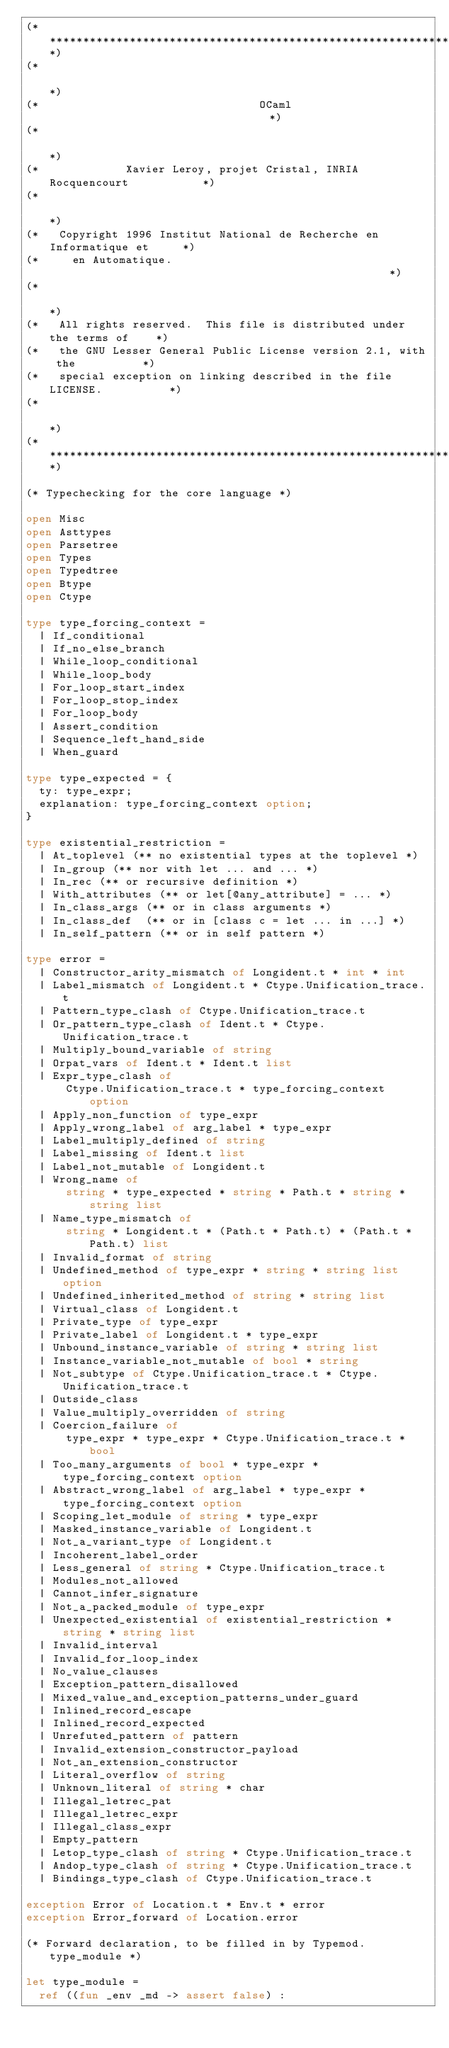<code> <loc_0><loc_0><loc_500><loc_500><_OCaml_>(**************************************************************************)
(*                                                                        *)
(*                                 OCaml                                  *)
(*                                                                        *)
(*             Xavier Leroy, projet Cristal, INRIA Rocquencourt           *)
(*                                                                        *)
(*   Copyright 1996 Institut National de Recherche en Informatique et     *)
(*     en Automatique.                                                    *)
(*                                                                        *)
(*   All rights reserved.  This file is distributed under the terms of    *)
(*   the GNU Lesser General Public License version 2.1, with the          *)
(*   special exception on linking described in the file LICENSE.          *)
(*                                                                        *)
(**************************************************************************)

(* Typechecking for the core language *)

open Misc
open Asttypes
open Parsetree
open Types
open Typedtree
open Btype
open Ctype

type type_forcing_context =
  | If_conditional
  | If_no_else_branch
  | While_loop_conditional
  | While_loop_body
  | For_loop_start_index
  | For_loop_stop_index
  | For_loop_body
  | Assert_condition
  | Sequence_left_hand_side
  | When_guard

type type_expected = {
  ty: type_expr;
  explanation: type_forcing_context option;
}

type existential_restriction =
  | At_toplevel (** no existential types at the toplevel *)
  | In_group (** nor with let ... and ... *)
  | In_rec (** or recursive definition *)
  | With_attributes (** or let[@any_attribute] = ... *)
  | In_class_args (** or in class arguments *)
  | In_class_def  (** or in [class c = let ... in ...] *)
  | In_self_pattern (** or in self pattern *)

type error =
  | Constructor_arity_mismatch of Longident.t * int * int
  | Label_mismatch of Longident.t * Ctype.Unification_trace.t
  | Pattern_type_clash of Ctype.Unification_trace.t
  | Or_pattern_type_clash of Ident.t * Ctype.Unification_trace.t
  | Multiply_bound_variable of string
  | Orpat_vars of Ident.t * Ident.t list
  | Expr_type_clash of
      Ctype.Unification_trace.t * type_forcing_context option
  | Apply_non_function of type_expr
  | Apply_wrong_label of arg_label * type_expr
  | Label_multiply_defined of string
  | Label_missing of Ident.t list
  | Label_not_mutable of Longident.t
  | Wrong_name of
      string * type_expected * string * Path.t * string * string list
  | Name_type_mismatch of
      string * Longident.t * (Path.t * Path.t) * (Path.t * Path.t) list
  | Invalid_format of string
  | Undefined_method of type_expr * string * string list option
  | Undefined_inherited_method of string * string list
  | Virtual_class of Longident.t
  | Private_type of type_expr
  | Private_label of Longident.t * type_expr
  | Unbound_instance_variable of string * string list
  | Instance_variable_not_mutable of bool * string
  | Not_subtype of Ctype.Unification_trace.t * Ctype.Unification_trace.t
  | Outside_class
  | Value_multiply_overridden of string
  | Coercion_failure of
      type_expr * type_expr * Ctype.Unification_trace.t * bool
  | Too_many_arguments of bool * type_expr * type_forcing_context option
  | Abstract_wrong_label of arg_label * type_expr * type_forcing_context option
  | Scoping_let_module of string * type_expr
  | Masked_instance_variable of Longident.t
  | Not_a_variant_type of Longident.t
  | Incoherent_label_order
  | Less_general of string * Ctype.Unification_trace.t
  | Modules_not_allowed
  | Cannot_infer_signature
  | Not_a_packed_module of type_expr
  | Unexpected_existential of existential_restriction * string * string list
  | Invalid_interval
  | Invalid_for_loop_index
  | No_value_clauses
  | Exception_pattern_disallowed
  | Mixed_value_and_exception_patterns_under_guard
  | Inlined_record_escape
  | Inlined_record_expected
  | Unrefuted_pattern of pattern
  | Invalid_extension_constructor_payload
  | Not_an_extension_constructor
  | Literal_overflow of string
  | Unknown_literal of string * char
  | Illegal_letrec_pat
  | Illegal_letrec_expr
  | Illegal_class_expr
  | Empty_pattern
  | Letop_type_clash of string * Ctype.Unification_trace.t
  | Andop_type_clash of string * Ctype.Unification_trace.t
  | Bindings_type_clash of Ctype.Unification_trace.t

exception Error of Location.t * Env.t * error
exception Error_forward of Location.error

(* Forward declaration, to be filled in by Typemod.type_module *)

let type_module =
  ref ((fun _env _md -> assert false) :</code> 